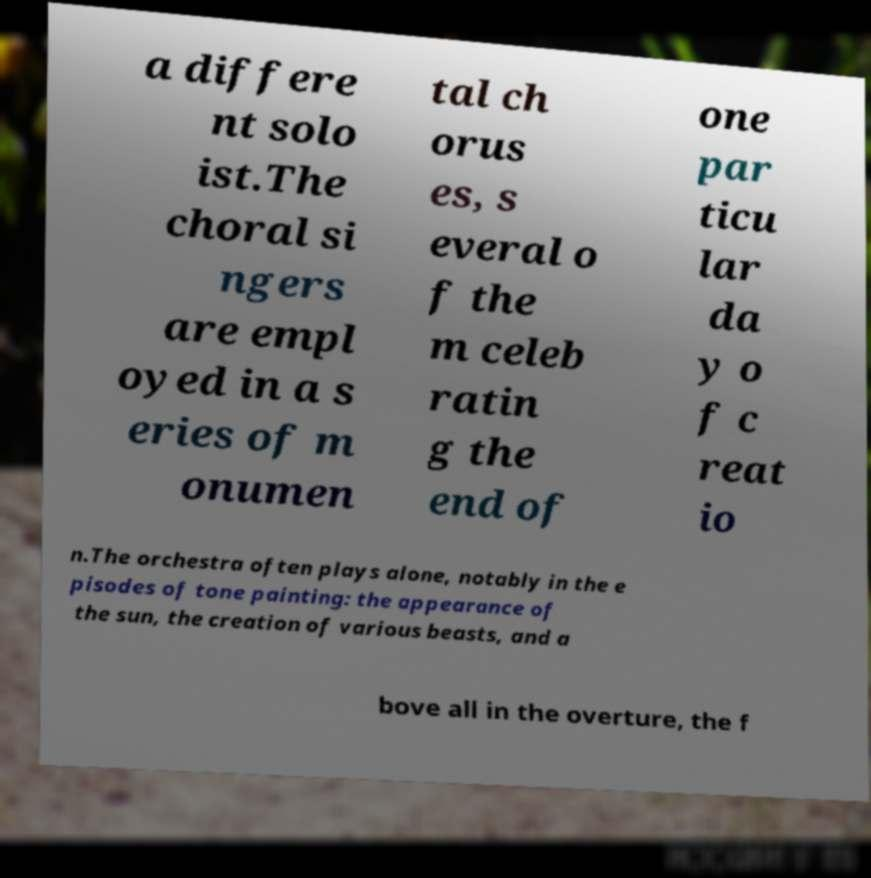For documentation purposes, I need the text within this image transcribed. Could you provide that? a differe nt solo ist.The choral si ngers are empl oyed in a s eries of m onumen tal ch orus es, s everal o f the m celeb ratin g the end of one par ticu lar da y o f c reat io n.The orchestra often plays alone, notably in the e pisodes of tone painting: the appearance of the sun, the creation of various beasts, and a bove all in the overture, the f 